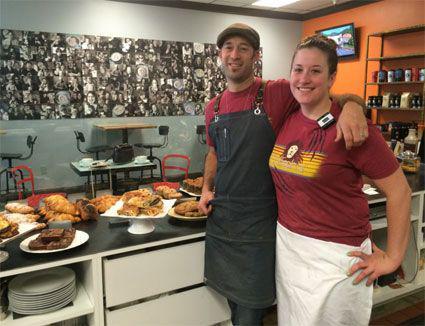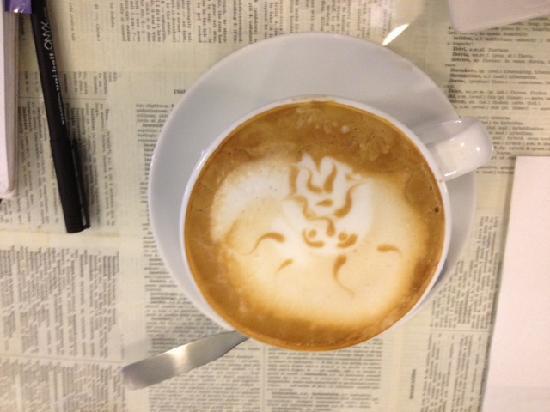The first image is the image on the left, the second image is the image on the right. Given the left and right images, does the statement "The left image includes a man wearing black on top standing in front of a counter, and a white tray containing food." hold true? Answer yes or no. Yes. The first image is the image on the left, the second image is the image on the right. Evaluate the accuracy of this statement regarding the images: "There are customers sitting.". Is it true? Answer yes or no. No. 